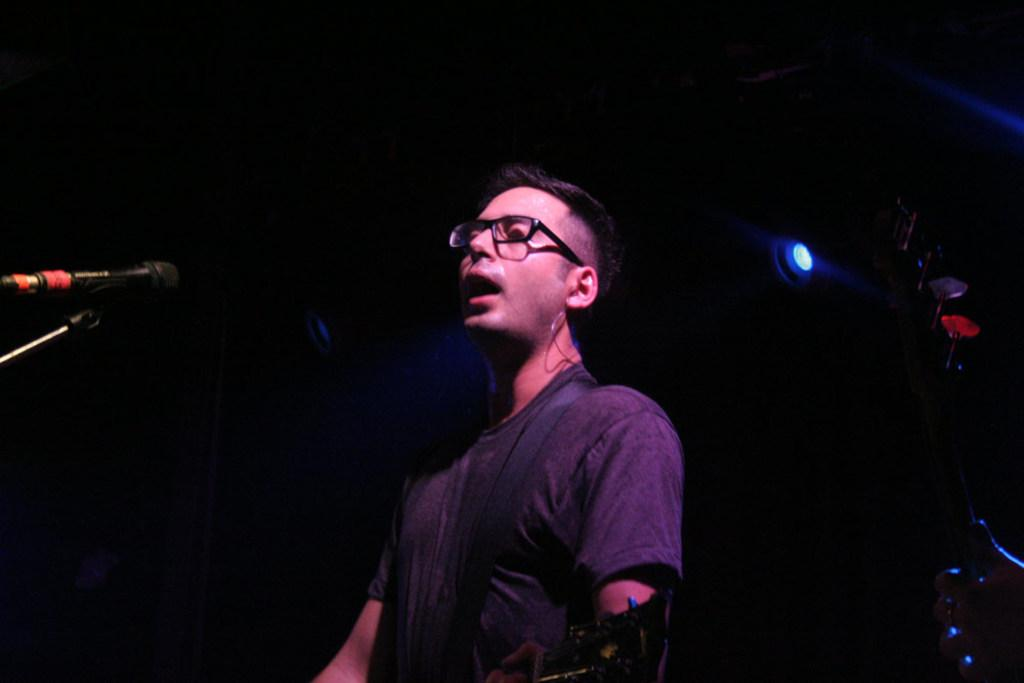What is the person in the image doing? The person is playing a guitar and singing. What object is the person using to amplify their voice? There is a mic in the image. What type of light is present in the image? There is a focusing light in the image. What type of lipstick is the person wearing in the image? There is no mention of lipstick or any cosmetic products in the image. What type of magic trick is the person performing in the image? There is no mention of a magic trick or any magical elements in the image. 